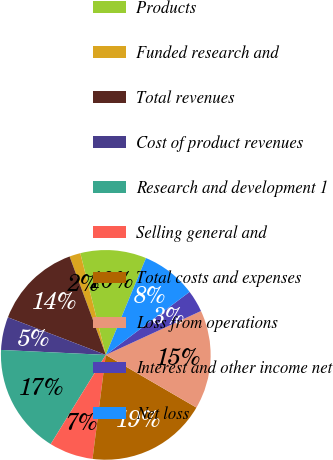Convert chart. <chart><loc_0><loc_0><loc_500><loc_500><pie_chart><fcel>Products<fcel>Funded research and<fcel>Total revenues<fcel>Cost of product revenues<fcel>Research and development 1<fcel>Selling general and<fcel>Total costs and expenses<fcel>Loss from operations<fcel>Interest and other income net<fcel>Net loss<nl><fcel>10.17%<fcel>1.7%<fcel>13.56%<fcel>5.08%<fcel>16.95%<fcel>6.78%<fcel>18.64%<fcel>15.25%<fcel>3.39%<fcel>8.47%<nl></chart> 